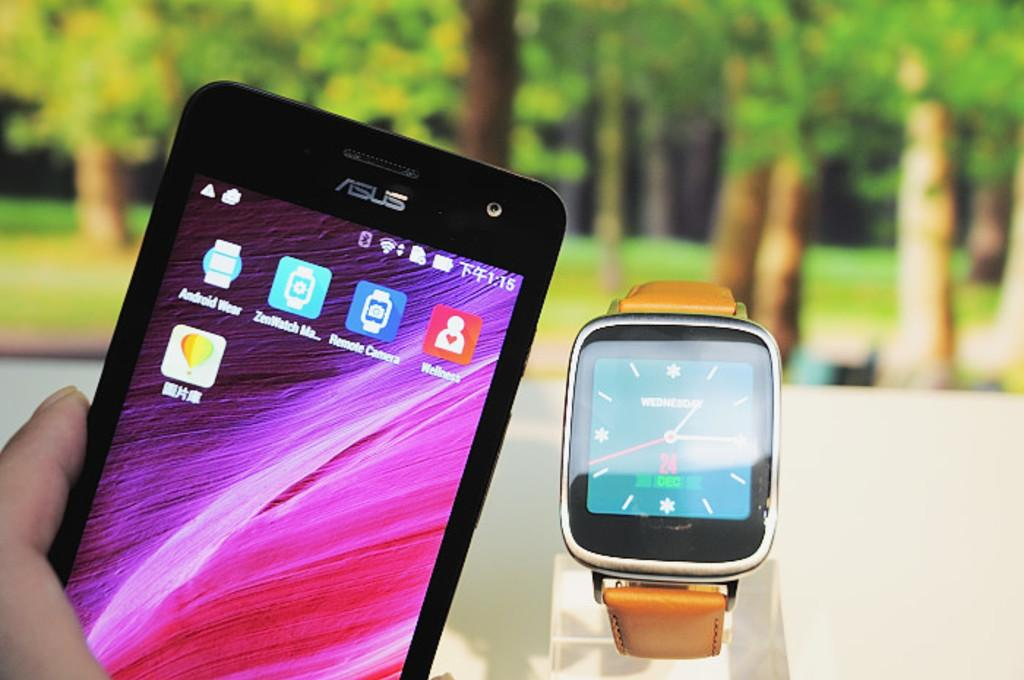<image>
Render a clear and concise summary of the photo. A bright purple screen is on an Asus cell phone. 